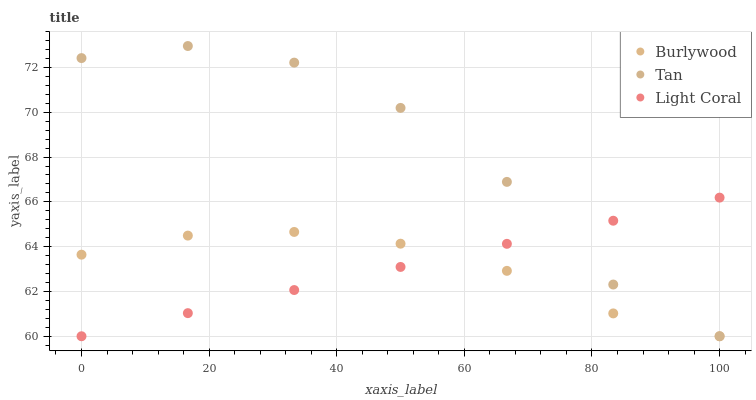Does Light Coral have the minimum area under the curve?
Answer yes or no. Yes. Does Tan have the maximum area under the curve?
Answer yes or no. Yes. Does Tan have the minimum area under the curve?
Answer yes or no. No. Does Light Coral have the maximum area under the curve?
Answer yes or no. No. Is Light Coral the smoothest?
Answer yes or no. Yes. Is Tan the roughest?
Answer yes or no. Yes. Is Tan the smoothest?
Answer yes or no. No. Is Light Coral the roughest?
Answer yes or no. No. Does Burlywood have the lowest value?
Answer yes or no. Yes. Does Tan have the highest value?
Answer yes or no. Yes. Does Light Coral have the highest value?
Answer yes or no. No. Does Burlywood intersect Light Coral?
Answer yes or no. Yes. Is Burlywood less than Light Coral?
Answer yes or no. No. Is Burlywood greater than Light Coral?
Answer yes or no. No. 